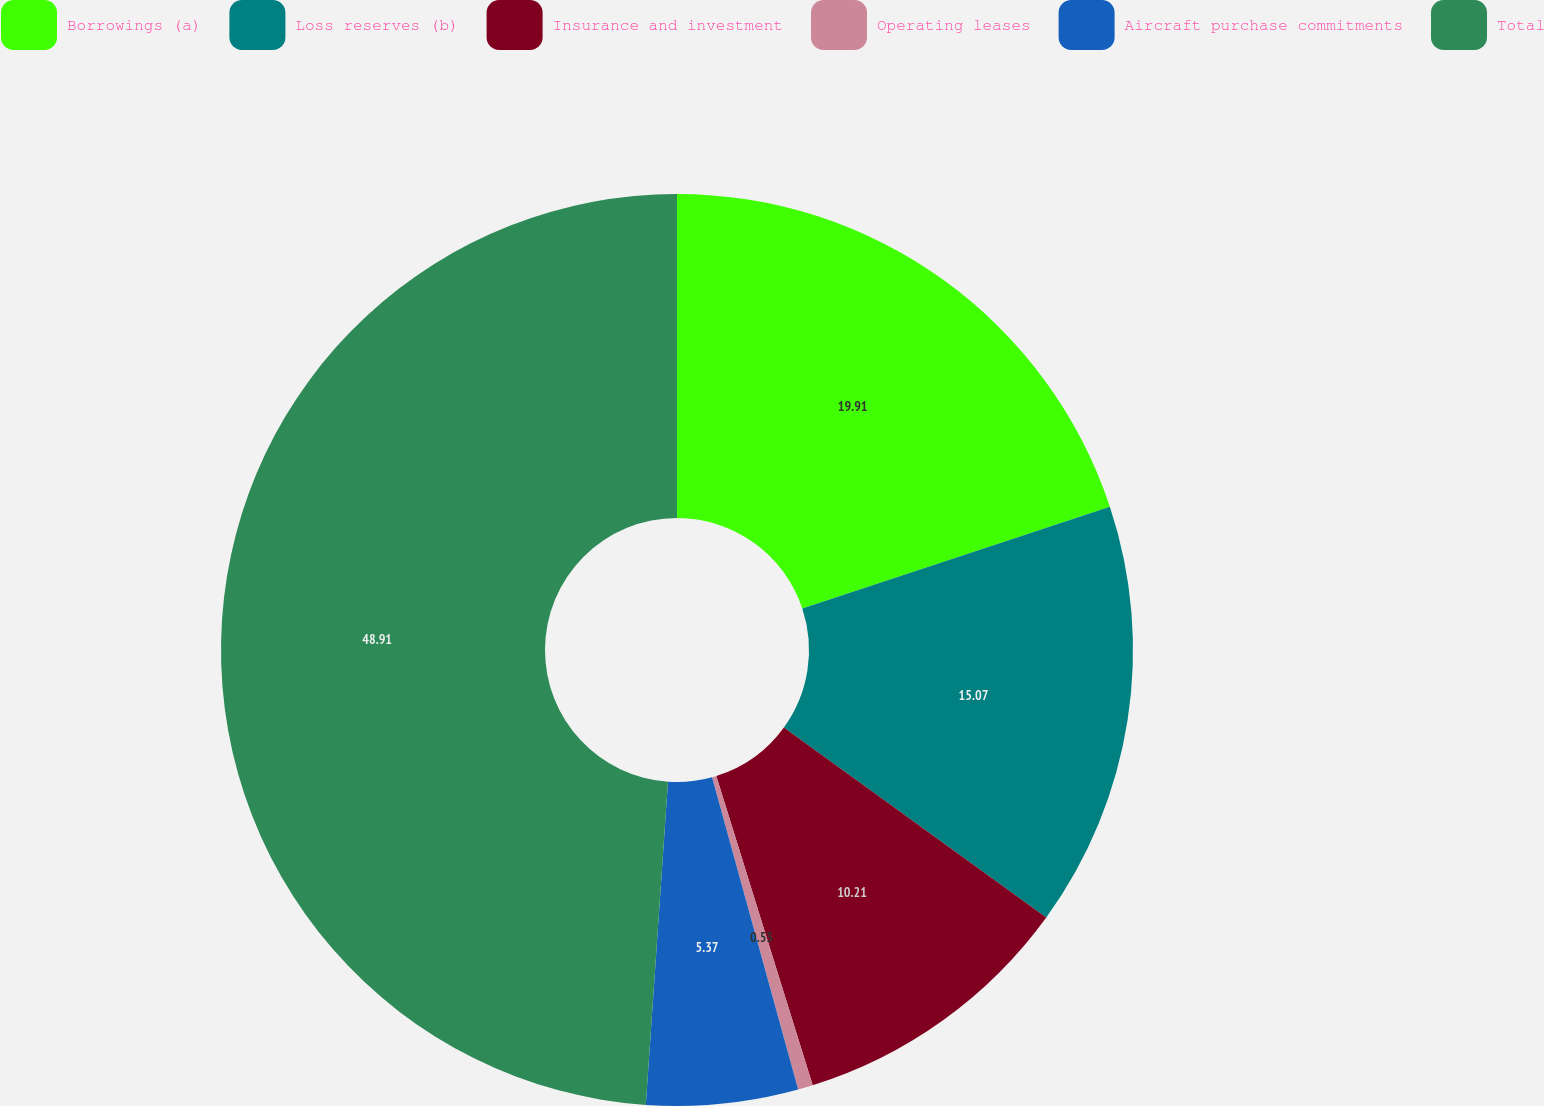Convert chart to OTSL. <chart><loc_0><loc_0><loc_500><loc_500><pie_chart><fcel>Borrowings (a)<fcel>Loss reserves (b)<fcel>Insurance and investment<fcel>Operating leases<fcel>Aircraft purchase commitments<fcel>Total<nl><fcel>19.91%<fcel>15.07%<fcel>10.21%<fcel>0.53%<fcel>5.37%<fcel>48.91%<nl></chart> 